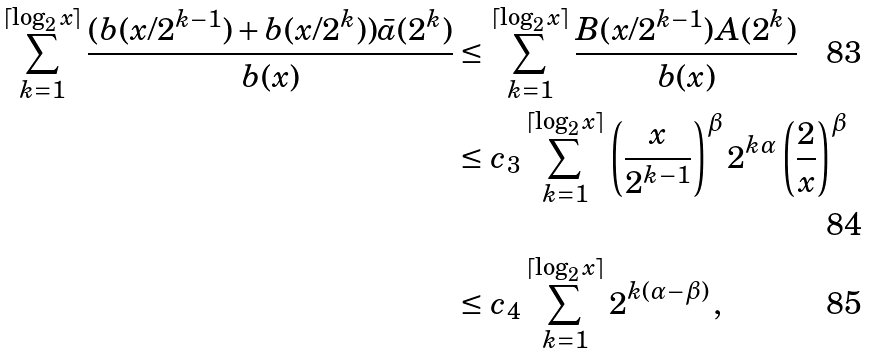Convert formula to latex. <formula><loc_0><loc_0><loc_500><loc_500>\sum _ { k = 1 } ^ { \lceil \log _ { 2 } x \rceil } \frac { ( b ( x / 2 ^ { k - 1 } ) + b ( x / 2 ^ { k } ) ) \bar { a } ( 2 ^ { k } ) } { b ( x ) } & \leq \sum _ { k = 1 } ^ { \lceil \log _ { 2 } x \rceil } \frac { B ( x / 2 ^ { k - 1 } ) A ( 2 ^ { k } ) } { b ( x ) } \\ & \leq c _ { 3 } \sum _ { k = 1 } ^ { \lceil \log _ { 2 } x \rceil } \left ( \frac { x } { 2 ^ { k - 1 } } \right ) ^ { \beta } 2 ^ { k \alpha } \left ( \frac { 2 } { x } \right ) ^ { \beta } \\ & \leq c _ { 4 } \sum _ { k = 1 } ^ { \lceil \log _ { 2 } x \rceil } 2 ^ { k ( \alpha - \beta ) } \, ,</formula> 